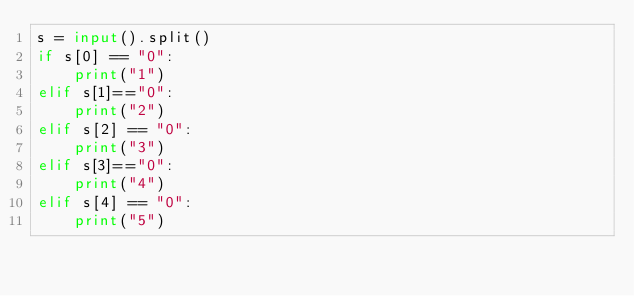<code> <loc_0><loc_0><loc_500><loc_500><_Python_>s = input().split()
if s[0] == "0":
    print("1")
elif s[1]=="0":
    print("2")
elif s[2] == "0":
    print("3")
elif s[3]=="0":
    print("4")
elif s[4] == "0":
    print("5")</code> 